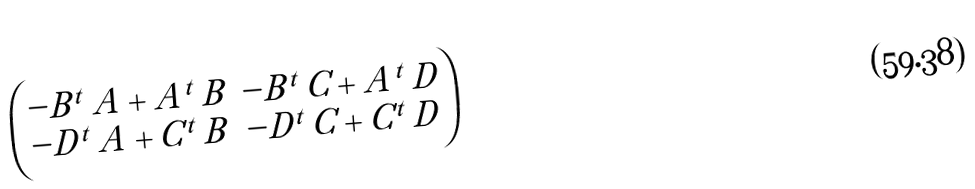Convert formula to latex. <formula><loc_0><loc_0><loc_500><loc_500>\begin{pmatrix} - B ^ { t } \, A + A ^ { t } \, B & - B ^ { t } \, C + A ^ { t } \, D \\ - D ^ { t } \, A + C ^ { t } \, B & - D ^ { t } \, C + C ^ { t } \, D \end{pmatrix}</formula> 